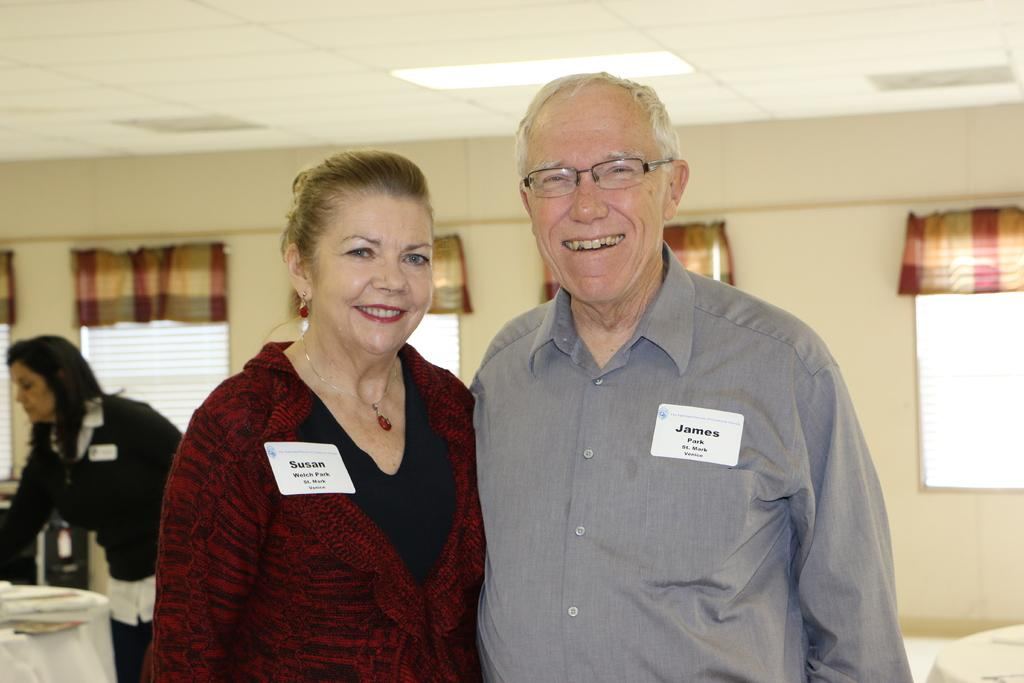How many people are present in the image? There are two people, a man and a woman, present in the image. Where are the man and woman located in the image? The man and woman are in the middle of the image. What can be seen in the background of the image? There are windows in the background of the image. Can you describe the woman on the left side of the image? There is a woman standing on the left side of the image. What is visible at the top of the image? There is a light at the top of the image. What type of jelly can be seen in the image? There is no jelly present in the image. Can you describe the truck parked outside the windows in the image? There is no truck visible in the image; only windows are mentioned in the background. 